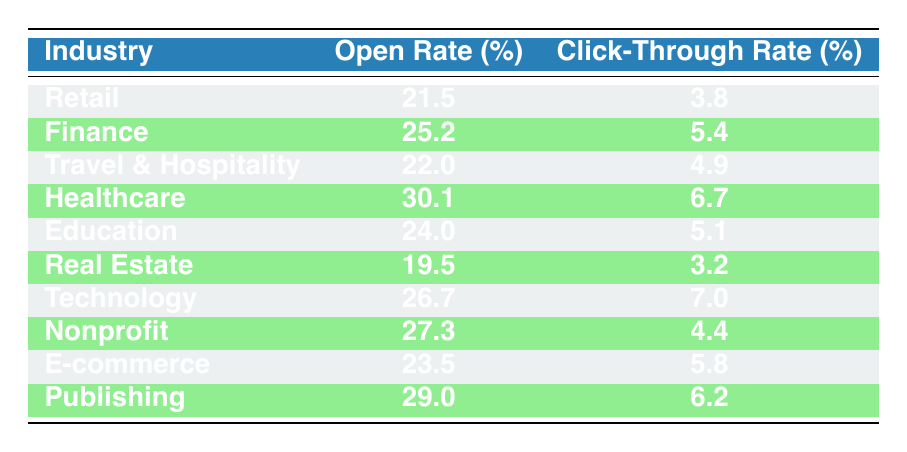What is the open rate for the Healthcare industry? The table clearly shows the metrics for each industry. The row for Healthcare shows an open rate of 30.1 percent.
Answer: 30.1 Which industry has the highest click-through rate? By examining the click-through rates in each row, Technology has the highest rate at 7.0 percent.
Answer: Technology What is the average open rate across all industries listed? To find the average open rate, add all open rates: (21.5 + 25.2 + 22.0 + 30.1 + 24.0 + 19.5 + 26.7 + 27.3 + 23.5 + 29) =  27.5. Then, divide by the number of industries (10), giving an average of 27.5 percent.
Answer: 27.5 Does the E-commerce industry have a higher click-through rate than the Retail industry? The E-commerce click-through rate is 5.8 percent, while Retail's is 3.8 percent, which means E-commerce does have a higher rate.
Answer: Yes What is the difference between the open rates of the lowest and highest industries? The lowest open rate is Real Estate at 19.5 percent and the highest is Healthcare at 30.1 percent. The difference is 30.1 - 19.5 = 10.6 percent.
Answer: 10.6 Are the open rates for Nonprofit and Publishing industries the same? The small table contains open rates of 27.3 percent for Nonprofit and 29.0 percent for Publishing, indicating they are not the same.
Answer: No What is the total click-through rate for the Travel & Hospitality and Publishing industries combined? Add the click-through rates for Travel & Hospitality (4.9 percent) and Publishing (6.2 percent), resulting in a total of 4.9 + 6.2 = 11.1 percent.
Answer: 11.1 Which industry has a lower open rate, Finance or Education? Finance has an open rate of 25.2 percent while Education's is 24.0 percent; therefore, Education has the lower open rate.
Answer: Education What industry has an open rate that is closest to 30 percent? Looking at the table, Healthcare is the only industry with an open rate (30.1 percent) that is closest to 30 percent.
Answer: Healthcare 